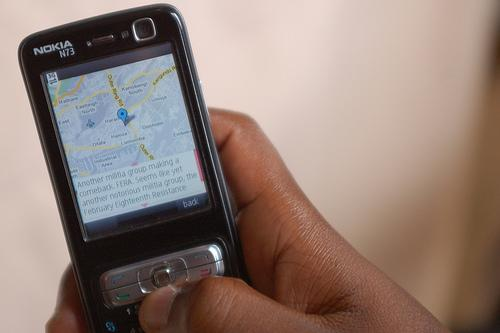Combine the central object and its color, along with the brand, in a brief description. A black Nokia cellphone being held in a person's hand. Identify the primary action involving the device in the image. Hand holding a black Nokia cell phone with a map on its screen. Briefly mention the primary object and its color in the picture. A black Nokia cell phone in a person's hand. In the image, state the type of phone and the screen activity. A black Nokia cell phone with a street map on its screen. What is the person holding in the image? The person is holding a black Nokia cell phone. What is being held in the image, and what content is shown on its screen? A black Nokia cell phone displaying a street map is being held. Using two key aspects, describe the phone in the picture. A black Nokia phone displaying a map in a person's hand. State the phone brand, its appearance, and its screen content in the image. A black Nokia cell phone in a hand with a map on its screen. Relate the fundamental subject and its feature in the picture. A black Nokia phone in hand, featuring a street map on its display. Summarize the main focus on the image by referring to the device and its brand. A Nokia cell phone held in a hand, showcasing its features. 